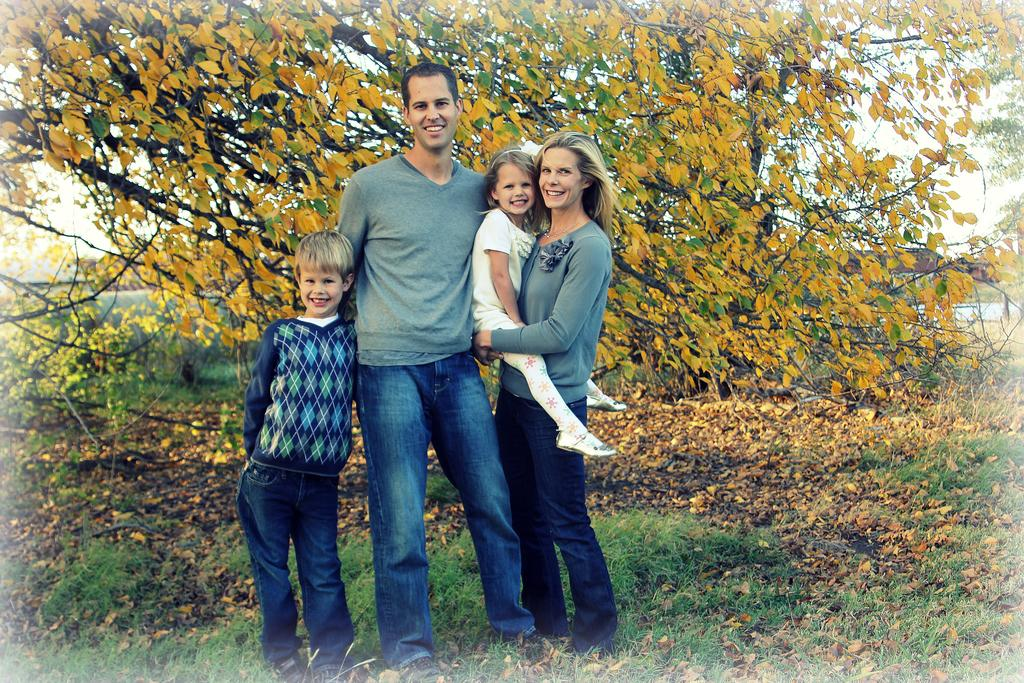How many people are in the image? There are four people in the image. What can be observed about the people's clothing? The people are wearing different color dresses. Where are the people standing? The people are standing on the grass. What expressions do the people have? The people are smiling. What can be seen in the background of the image? There are trees and the sky visible in the background of the image. What type of idea is being discussed by the people in the image? There is no indication in the image that the people are discussing any ideas. Can you see a toad in the image? There is no toad present in the image. 